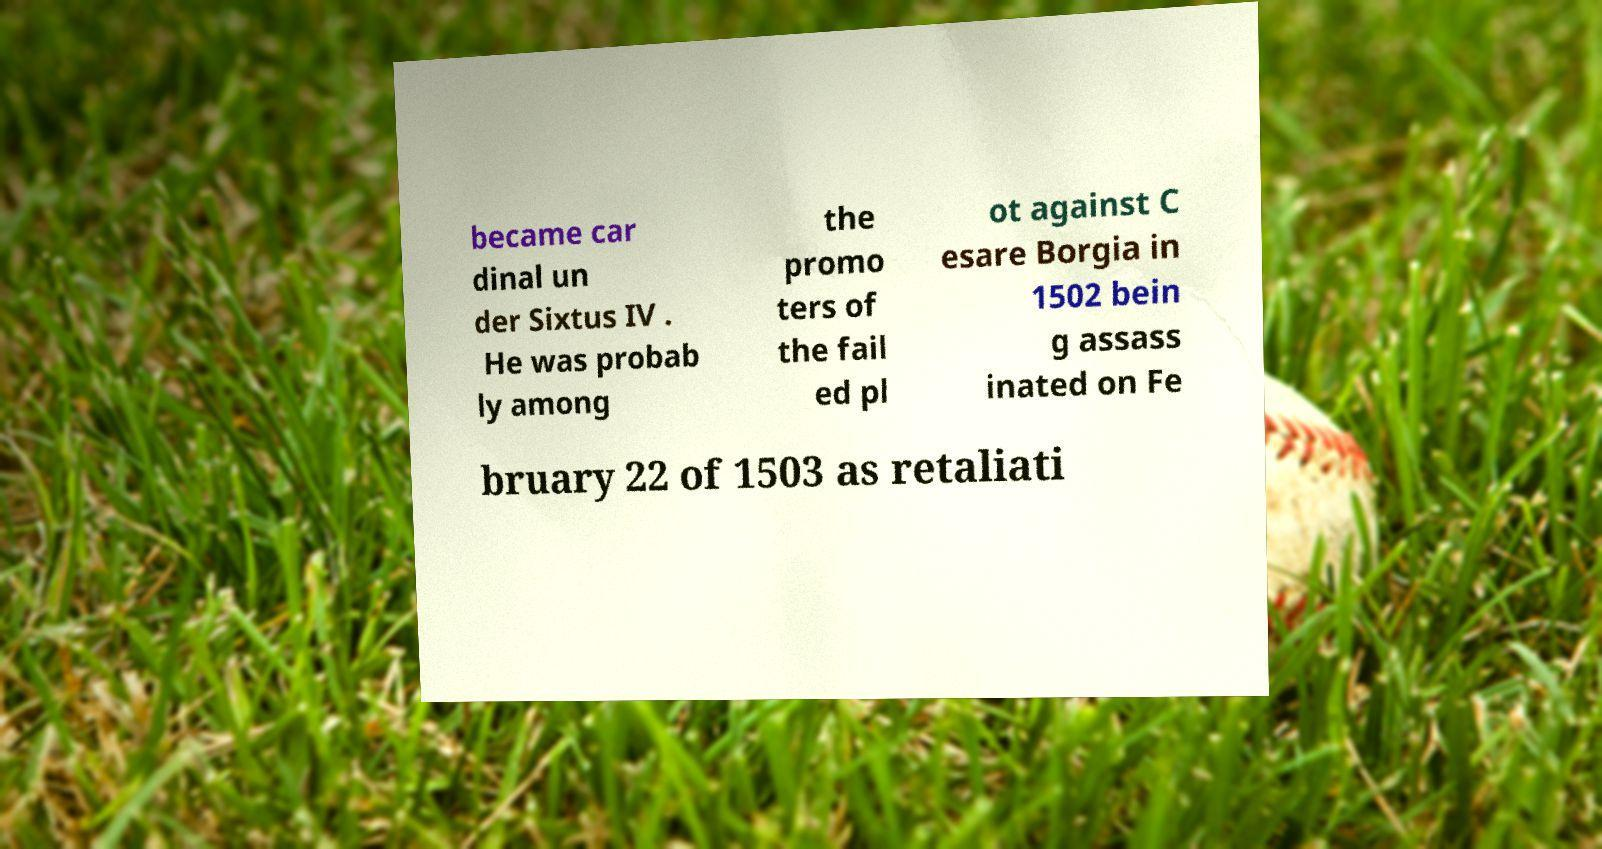Could you assist in decoding the text presented in this image and type it out clearly? became car dinal un der Sixtus IV . He was probab ly among the promo ters of the fail ed pl ot against C esare Borgia in 1502 bein g assass inated on Fe bruary 22 of 1503 as retaliati 